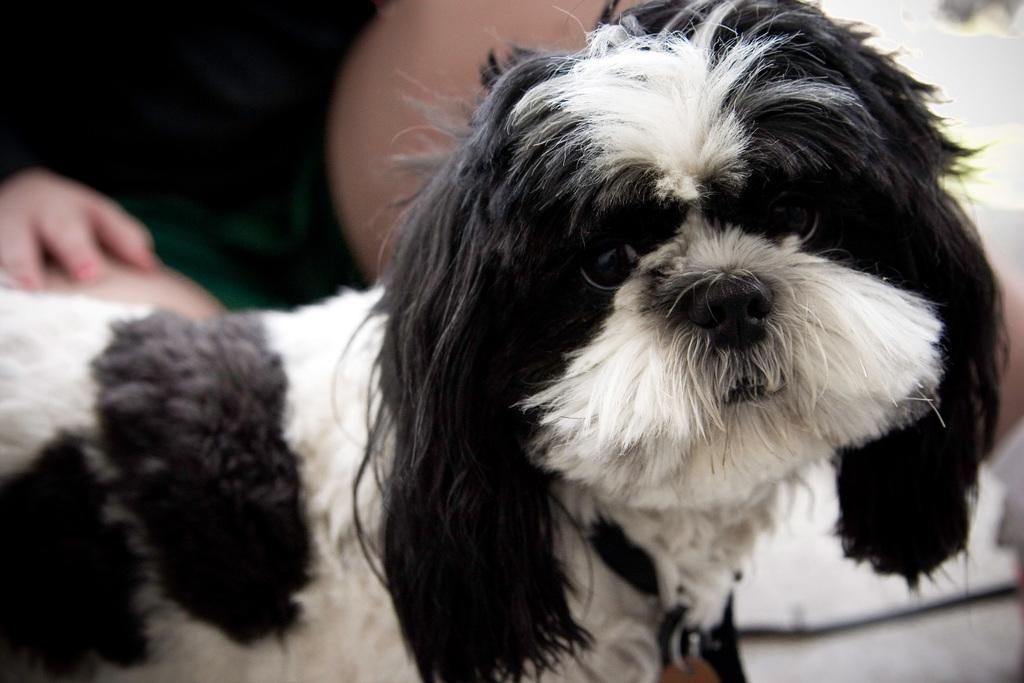Please provide a concise description of this image. In this picture there is a dog and we can see a person. 